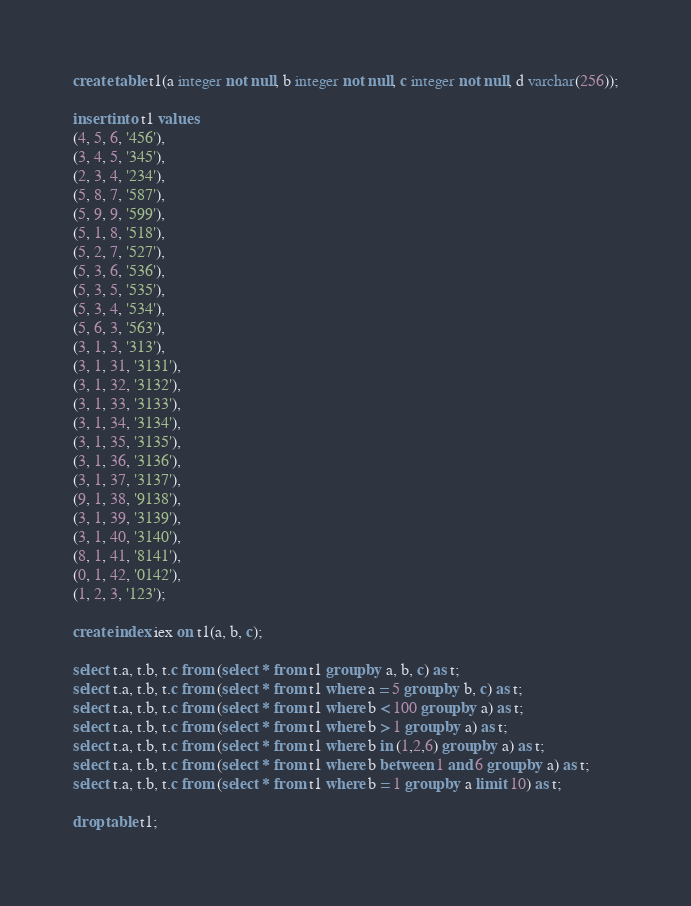<code> <loc_0><loc_0><loc_500><loc_500><_SQL_>create table t1(a integer not null, b integer not null, c integer not null, d varchar(256));

insert into t1 values 
(4, 5, 6, '456'), 
(3, 4, 5, '345'), 
(2, 3, 4, '234'), 
(5, 8, 7, '587'), 
(5, 9, 9, '599'), 
(5, 1, 8, '518'), 
(5, 2, 7, '527'), 
(5, 3, 6, '536'), 
(5, 3, 5, '535'), 
(5, 3, 4, '534'), 
(5, 6, 3, '563'), 
(3, 1, 3, '313'), 
(3, 1, 31, '3131'), 
(3, 1, 32, '3132'), 
(3, 1, 33, '3133'), 
(3, 1, 34, '3134'), 
(3, 1, 35, '3135'), 
(3, 1, 36, '3136'), 
(3, 1, 37, '3137'), 
(9, 1, 38, '9138'), 
(3, 1, 39, '3139'), 
(3, 1, 40, '3140'), 
(8, 1, 41, '8141'), 
(0, 1, 42, '0142'), 
(1, 2, 3, '123');

create index iex on t1(a, b, c);

select t.a, t.b, t.c from (select * from t1 group by a, b, c) as t;
select t.a, t.b, t.c from (select * from t1 where a = 5 group by b, c) as t;
select t.a, t.b, t.c from (select * from t1 where b < 100 group by a) as t;
select t.a, t.b, t.c from (select * from t1 where b > 1 group by a) as t;
select t.a, t.b, t.c from (select * from t1 where b in (1,2,6) group by a) as t;
select t.a, t.b, t.c from (select * from t1 where b between 1 and 6 group by a) as t;
select t.a, t.b, t.c from (select * from t1 where b = 1 group by a limit 10) as t;

drop table t1;
</code> 